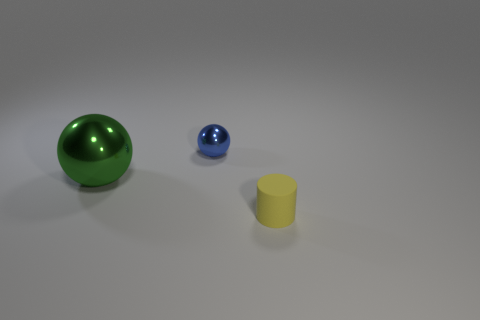Subtract all cyan cylinders. Subtract all brown cubes. How many cylinders are left? 1 Add 3 small blue metallic cubes. How many objects exist? 6 Subtract all balls. How many objects are left? 1 Subtract 1 green balls. How many objects are left? 2 Subtract all small green metal cylinders. Subtract all big green metallic things. How many objects are left? 2 Add 2 tiny yellow matte cylinders. How many tiny yellow matte cylinders are left? 3 Add 2 blue shiny spheres. How many blue shiny spheres exist? 3 